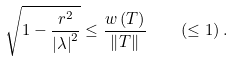<formula> <loc_0><loc_0><loc_500><loc_500>\sqrt { 1 - \frac { r ^ { 2 } } { \left | \lambda \right | ^ { 2 } } } \leq \frac { w \left ( T \right ) } { \left \| T \right \| } \quad \left ( \leq 1 \right ) .</formula> 